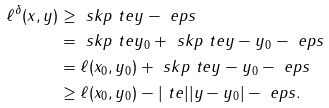Convert formula to latex. <formula><loc_0><loc_0><loc_500><loc_500>\ell ^ { \delta } ( x , y ) & \geq \ s k p { \ t e } { y } - \ e p s \\ & = \ s k p { \ t e } { y _ { 0 } } + \ s k p { \ t e } { y - y _ { 0 } } - \ e p s \\ & = \ell ( x _ { 0 } , y _ { 0 } ) + \ s k p { \ t e } { y - y _ { 0 } } - \ e p s \\ & \geq \ell ( x _ { 0 } , y _ { 0 } ) - | \ t e | | y - y _ { 0 } | - \ e p s .</formula> 